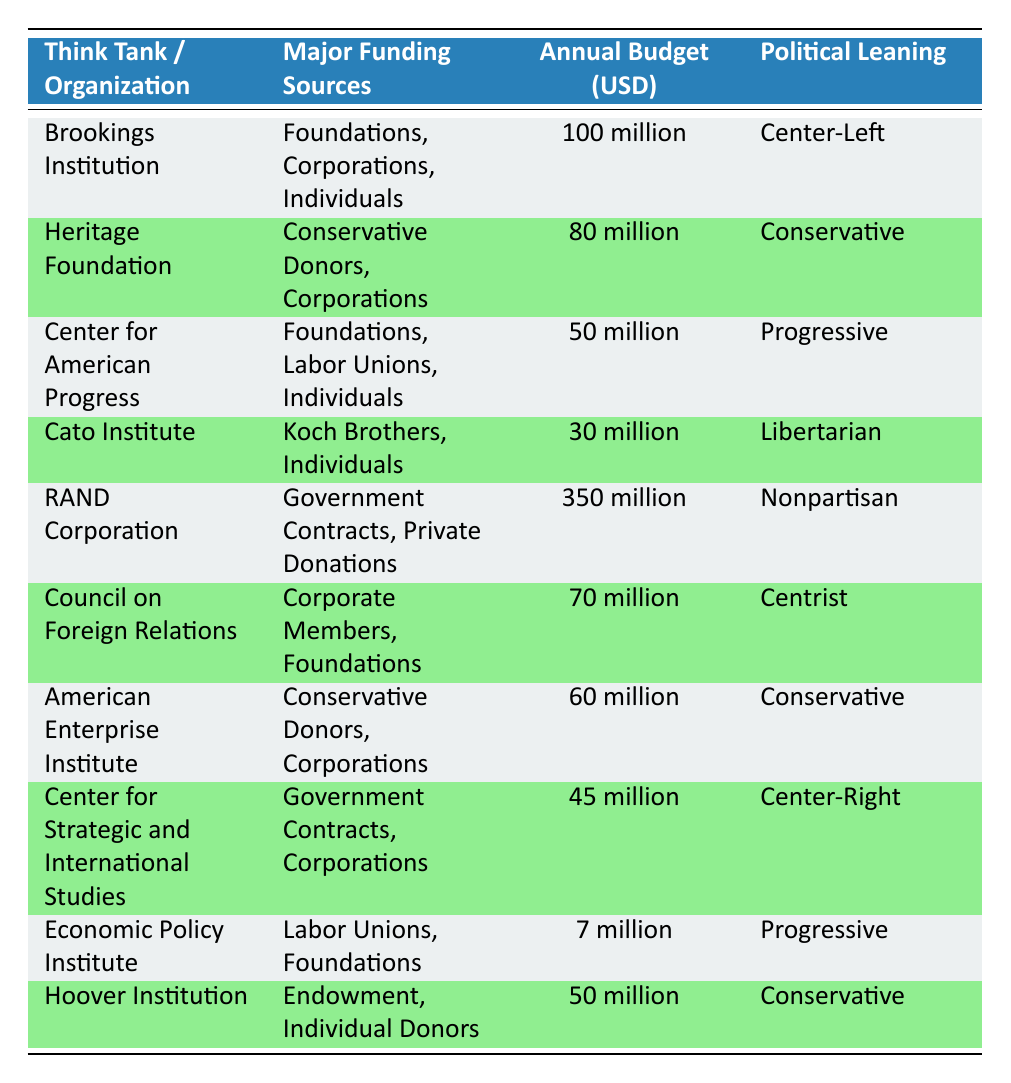What is the annual budget of the Brookings Institution? The annual budget of the Brookings Institution is clearly listed in the table under "Annual Budget (USD)." It shows "100 million" for this organization.
Answer: 100 million Which think tank has the largest annual budget? The "RAND Corporation" has the largest annual budget at "350 million," which is the highest amount listed in the table.
Answer: RAND Corporation How many think tanks have a conservative political leaning? The table lists three organizations with a conservative political leaning: "Heritage Foundation," "American Enterprise Institute," and "Hoover Institution."
Answer: Three What is the average annual budget of think tanks with a progressive political leaning? The think tanks with a progressive leaning are "Center for American Progress" (50 million) and "Economic Policy Institute" (7 million). The total budget is 50 + 7 = 57 million. Dividing by the number of organizations (2) gives 57/2 = 28.5 million.
Answer: 28.5 million Is the Heritage Foundation funded solely by conservative donors? According to the table, the Heritage Foundation is funded by "Conservative Donors, Corporations," indicating it has a mix of funding sources, so it is not solely funded by conservative donors.
Answer: No Which think tank relies on government contracts for funding? The "RAND Corporation" and "Center for Strategic and International Studies" are listed as receiving funding through government contracts, as seen in the "Major Funding Sources" column.
Answer: RAND Corporation; Center for Strategic and International Studies What is the total annual budget of non-progressive think tanks? Non-progressive think tanks in the table are "Brookings Institution" (100 million), "Heritage Foundation" (80 million), "Cato Institute" (30 million), "RAND Corporation" (350 million), "Council on Foreign Relations" (70 million), "American Enterprise Institute" (60 million), and "Center for Strategic and International Studies" (45 million). Adding these yields 100 + 80 + 30 + 350 + 70 + 60 + 45 = 735 million.
Answer: 735 million Which think tank has fewer than 10 million in annual budget? The table shows the "Economic Policy Institute" with an annual budget of "7 million," making it the only think tank with a budget under 10 million.
Answer: Economic Policy Institute 